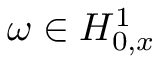<formula> <loc_0><loc_0><loc_500><loc_500>\omega \in H _ { 0 , x } ^ { 1 }</formula> 